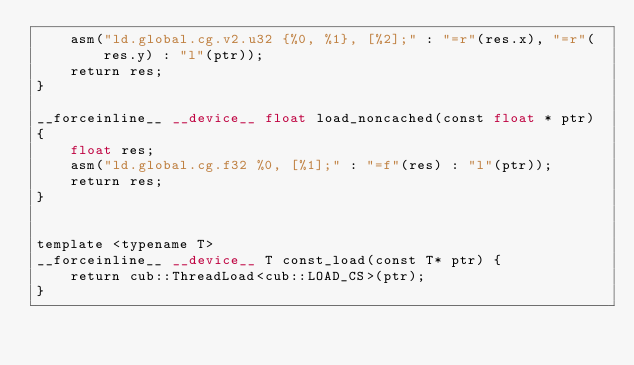<code> <loc_0><loc_0><loc_500><loc_500><_Cuda_>    asm("ld.global.cg.v2.u32 {%0, %1}, [%2];" : "=r"(res.x), "=r"(res.y) : "l"(ptr));
    return res;
}

__forceinline__ __device__ float load_noncached(const float * ptr)
{
    float res;
    asm("ld.global.cg.f32 %0, [%1];" : "=f"(res) : "l"(ptr));
    return res;
}


template <typename T>
__forceinline__ __device__ T const_load(const T* ptr) {
    return cub::ThreadLoad<cub::LOAD_CS>(ptr);
}
</code> 